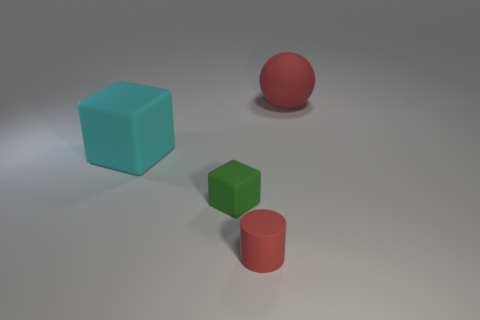There is a big matte object that is to the left of the red matte object that is behind the cyan thing; what shape is it?
Your answer should be compact. Cube. What shape is the small red thing that is made of the same material as the cyan cube?
Make the answer very short. Cylinder. Do the rubber object that is to the right of the cylinder and the object to the left of the tiny matte block have the same size?
Offer a very short reply. Yes. The large object that is to the left of the small red cylinder has what shape?
Offer a terse response. Cube. What is the color of the matte ball?
Offer a terse response. Red. There is a green object; is its size the same as the object that is in front of the green matte block?
Ensure brevity in your answer.  Yes. What number of matte objects are either big yellow things or large blocks?
Provide a succinct answer. 1. There is a large sphere; is it the same color as the cylinder that is left of the large red matte ball?
Your answer should be very brief. Yes. The cyan thing has what shape?
Make the answer very short. Cube. There is a red rubber object that is behind the large object on the left side of the big thing that is right of the tiny red cylinder; what is its size?
Make the answer very short. Large. 